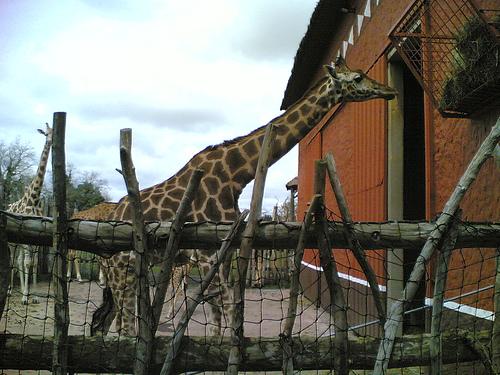Are there lots of trees?
Answer briefly. No. What animals are in the photograph?
Short answer required. Giraffe. What kinds of animals are these?
Short answer required. Giraffe. Who is standing here?
Write a very short answer. Giraffe. What color is the fence?
Be succinct. Brown. Are there trash cans?
Be succinct. No. Is this animal in the wild?
Concise answer only. No. What number of wires make up this fence?
Be succinct. 20. Is this animal from Europe?
Quick response, please. No. What materials the feed box made out of?
Answer briefly. Metal. Is this tree branch laying on it's side?
Quick response, please. No. What color is the building?
Write a very short answer. Red. Is there an umbrella in this image?
Short answer required. No. What is the giraffe eating?
Write a very short answer. Hay. 